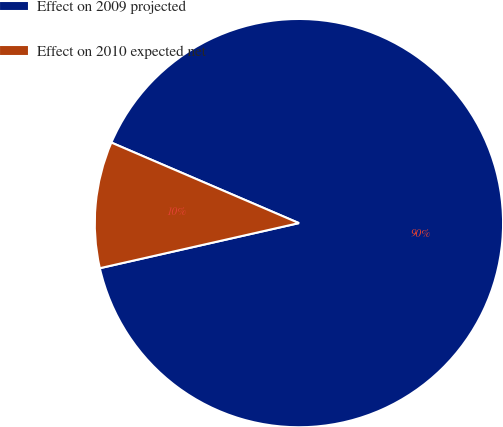Convert chart to OTSL. <chart><loc_0><loc_0><loc_500><loc_500><pie_chart><fcel>Effect on 2009 projected<fcel>Effect on 2010 expected net<nl><fcel>90.0%<fcel>10.0%<nl></chart> 